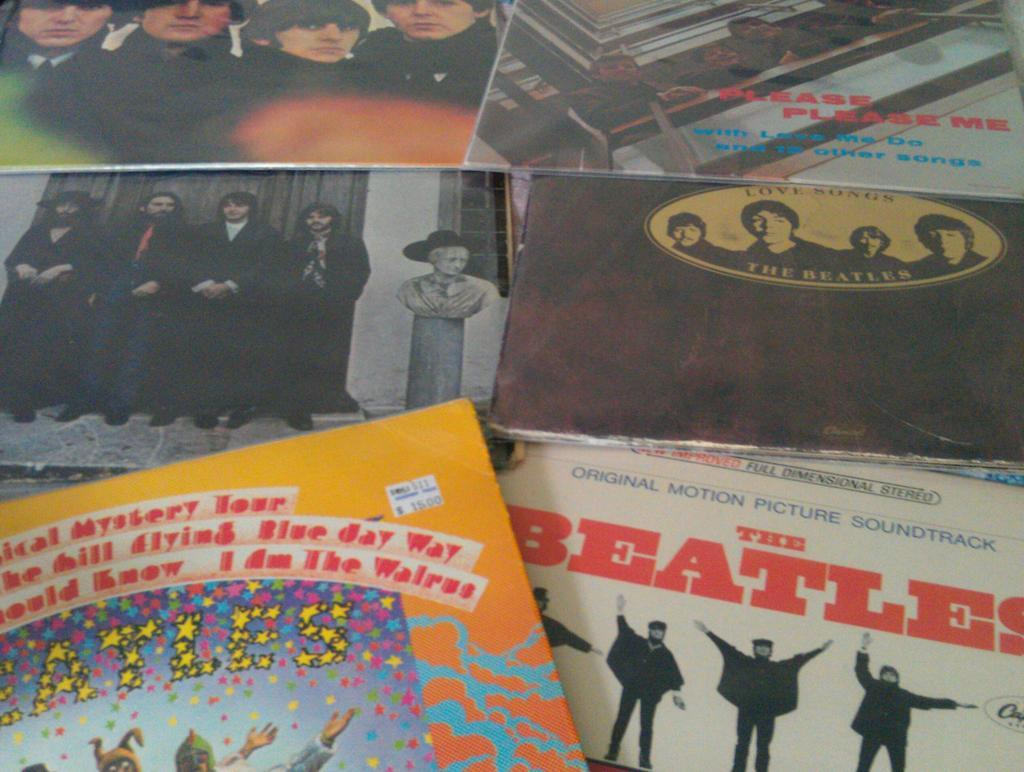Provide a one-sentence caption for the provided image. The beatles record and love songs by the beatles. 